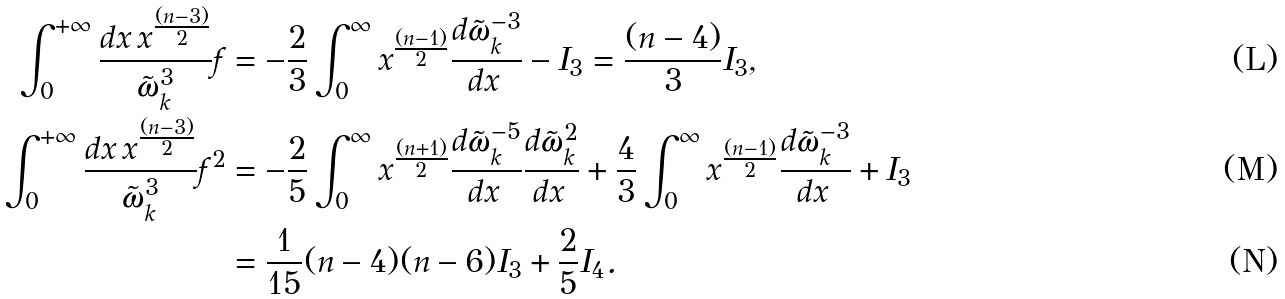Convert formula to latex. <formula><loc_0><loc_0><loc_500><loc_500>\int _ { 0 } ^ { + \infty } \frac { d x \, x ^ { \frac { ( n - 3 ) } { 2 } } } { \tilde { \omega } _ { k } ^ { 3 } } f & = - \frac { 2 } { 3 } \int _ { 0 } ^ { \infty } x ^ { \frac { ( n - 1 ) } { 2 } } \frac { d \tilde { \omega } _ { k } ^ { - 3 } } { d x \, } - I _ { 3 } = \frac { ( n - 4 ) } { 3 } I _ { 3 } , \\ \int _ { 0 } ^ { + \infty } \frac { d x \, x ^ { \frac { ( n - 3 ) } { 2 } } } { \tilde { \omega } _ { k } ^ { 3 } } f ^ { 2 } & = - \frac { 2 } { 5 } \int _ { 0 } ^ { \infty } x ^ { \frac { ( n + 1 ) } { 2 } } \frac { d \tilde { \omega } _ { k } ^ { - 5 } } { d x \, } \frac { d \tilde { \omega } _ { k } ^ { 2 } } { d x \, } + \frac { 4 } { 3 } \int _ { 0 } ^ { \infty } x ^ { \frac { ( n - 1 ) } { 2 } } \frac { d \tilde { \omega } _ { k } ^ { - 3 } } { d x \, } + I _ { 3 } \\ & = \frac { 1 } { 1 5 } ( n - 4 ) ( n - 6 ) I _ { 3 } + \frac { 2 } { 5 } I _ { 4 } .</formula> 